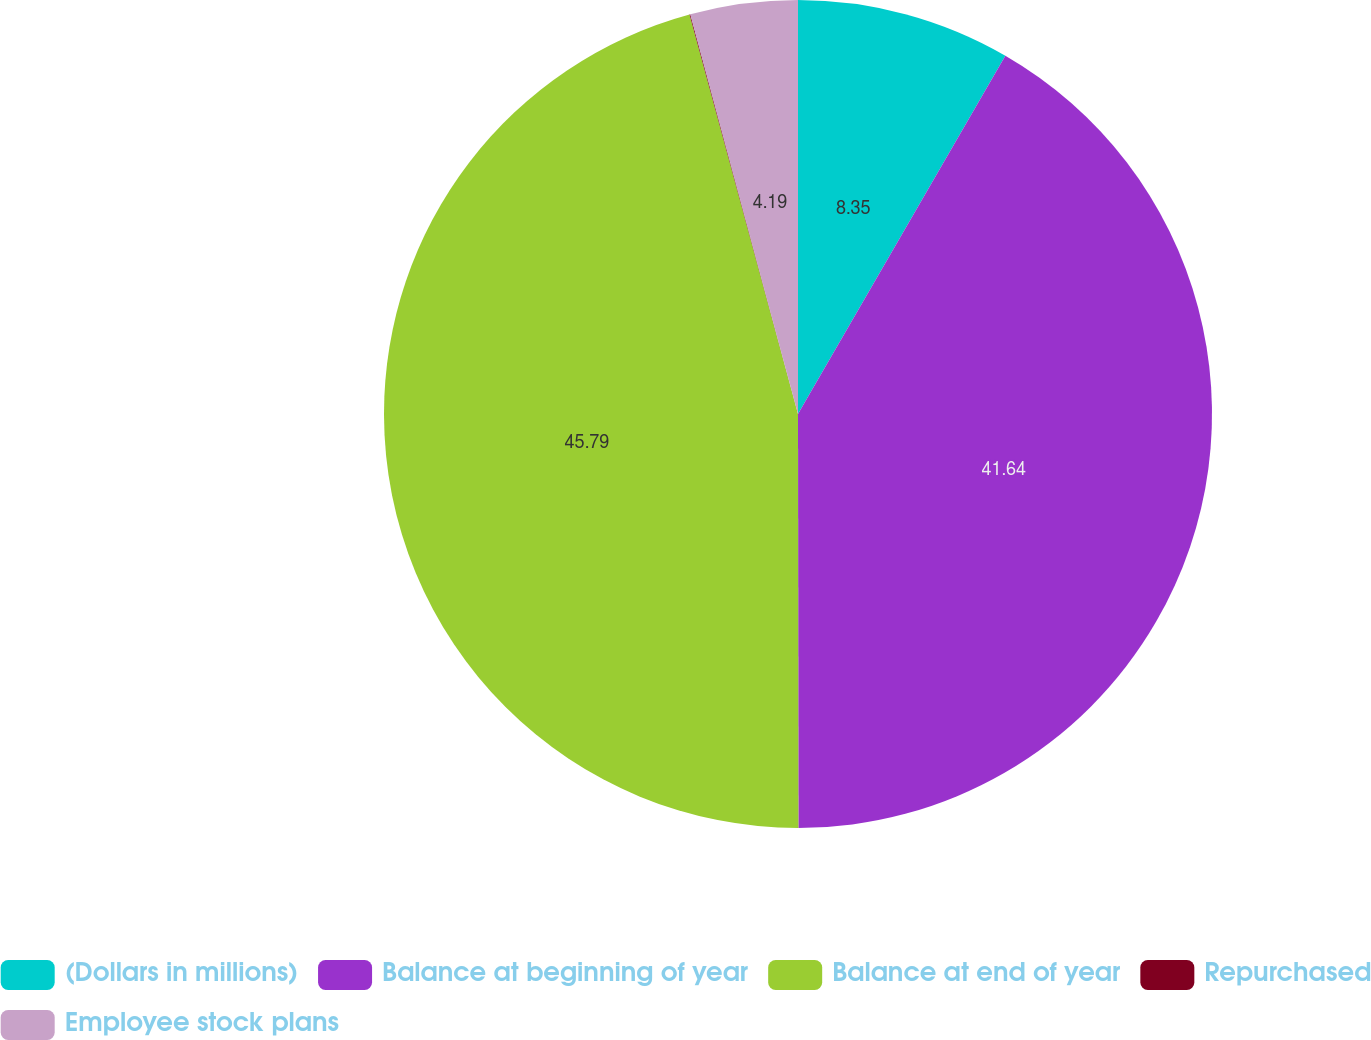Convert chart to OTSL. <chart><loc_0><loc_0><loc_500><loc_500><pie_chart><fcel>(Dollars in millions)<fcel>Balance at beginning of year<fcel>Balance at end of year<fcel>Repurchased<fcel>Employee stock plans<nl><fcel>8.35%<fcel>41.64%<fcel>45.8%<fcel>0.03%<fcel>4.19%<nl></chart> 